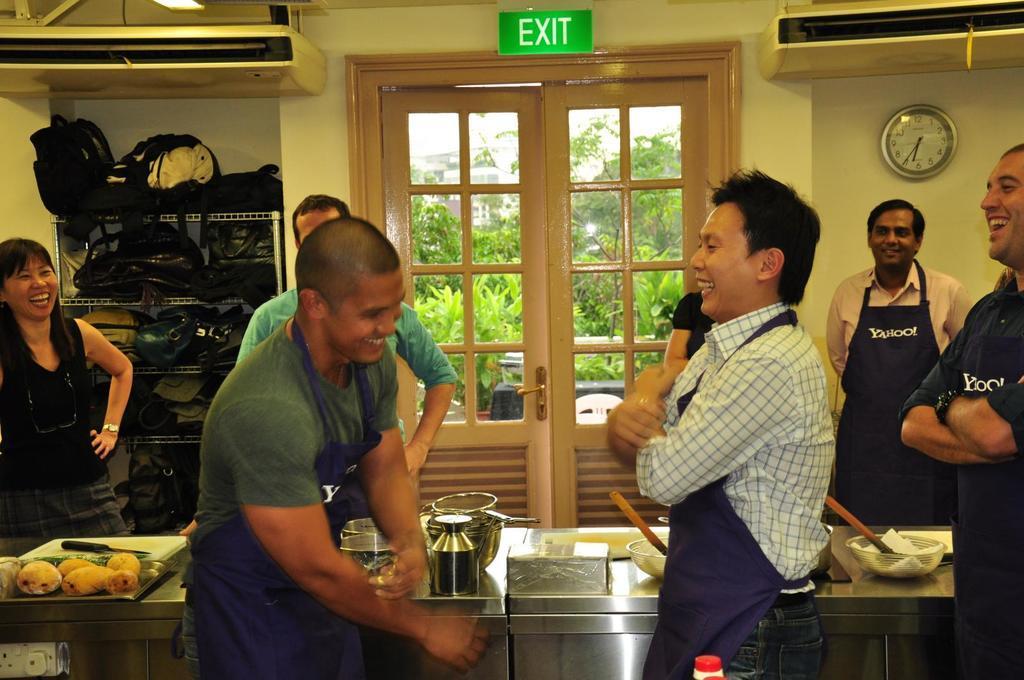Describe this image in one or two sentences. In this image I can see a person wearing white shirt and a person wearing green t shirt are standing in front of a metal table and on the table I can see few utensils, a tray with few food items in it, a knife, few bowls and few other objects and I can see few other persons standing around the table. In the background I can see the wall, a clock, a rack with few objects in it and the door through which I can see few trees, few buildings and the sky. 